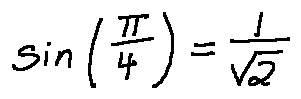<formula> <loc_0><loc_0><loc_500><loc_500>\sin ( \frac { \pi } { 4 } ) = \frac { 1 } { \sqrt { 2 } }</formula> 